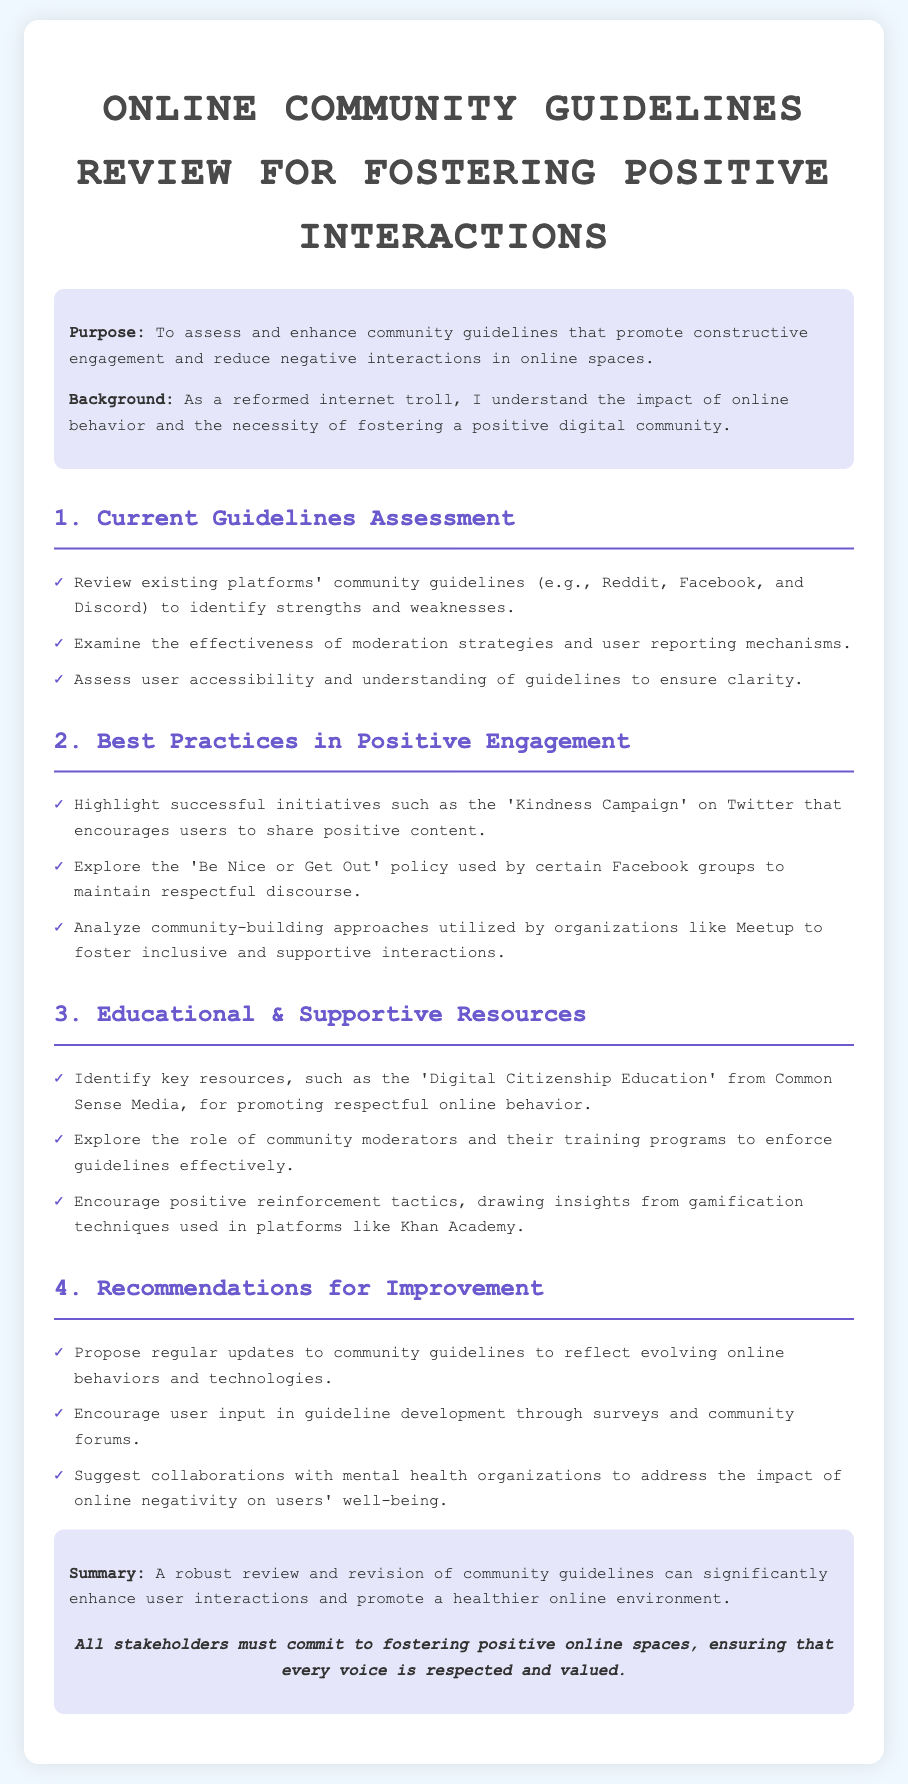What is the purpose of the guidelines review? The purpose is to assess and enhance community guidelines that promote constructive engagement and reduce negative interactions in online spaces.
Answer: To assess and enhance community guidelines Who is the intended audience or stakeholder of the review? The intended audience stems from the context set in the introduction, highlighting the need for a positive digital community.
Answer: Online community members What is one initiative that encourages positive content on social media? The document lists successful initiatives, one being the 'Kindness Campaign' on Twitter.
Answer: Kindness Campaign Which Facebook policy is mentioned to maintain respectful discourse? The document refers to the 'Be Nice or Get Out' policy as a practice used by certain Facebook groups.
Answer: Be Nice or Get Out How many main sections are in the document? The sections are clearly numbered and divided, counting to four main areas in the guideline review.
Answer: Four What resource is highlighted for promoting respectful online behavior? The document identifies 'Digital Citizenship Education' from Common Sense Media as a key resource.
Answer: Digital Citizenship Education What does the conclusion suggest must be done by all stakeholders? The conclusion emphasizes a commitment to fostering positive online spaces, ensuring every voice is respected.
Answer: Commit to fostering positive online spaces How often should community guidelines be updated according to the recommendations? The recommendations propose regular updates to reflect evolving online behaviors and technologies.
Answer: Regular updates What role do community moderators play according to the document? The document notes that community moderators have a significant role in enforcing guidelines effectively.
Answer: Enforcing guidelines effectively 